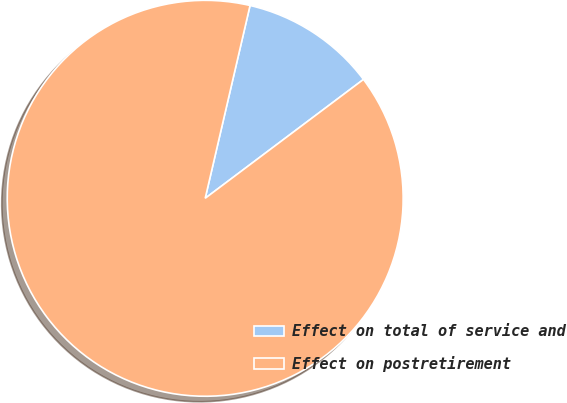Convert chart. <chart><loc_0><loc_0><loc_500><loc_500><pie_chart><fcel>Effect on total of service and<fcel>Effect on postretirement<nl><fcel>11.11%<fcel>88.89%<nl></chart> 